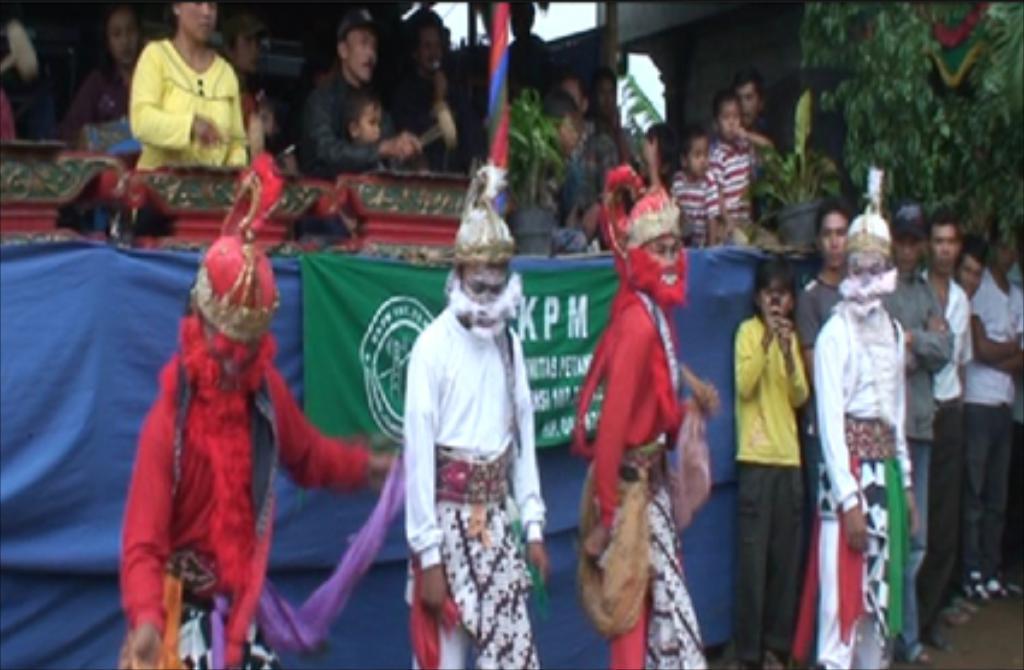Please provide a concise description of this image. In this image there are person standing. In the center there is a banner with some text written on it. In the background there are plants and there is a wall. 